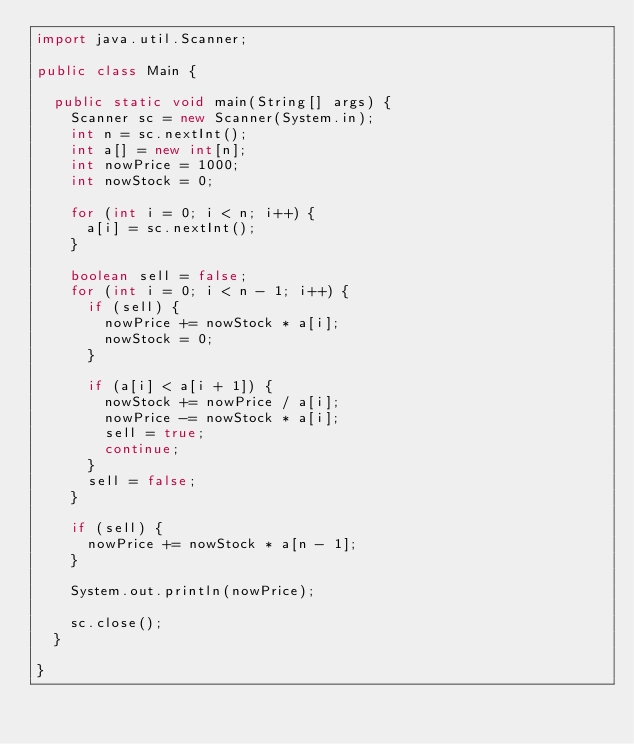<code> <loc_0><loc_0><loc_500><loc_500><_Java_>import java.util.Scanner;

public class Main {

	public static void main(String[] args) {
		Scanner sc = new Scanner(System.in);
		int n = sc.nextInt();
		int a[] = new int[n];
		int nowPrice = 1000;
		int nowStock = 0;

		for (int i = 0; i < n; i++) {
			a[i] = sc.nextInt();
		}

		boolean sell = false;
		for (int i = 0; i < n - 1; i++) {
			if (sell) {
				nowPrice += nowStock * a[i];
				nowStock = 0;
			}

			if (a[i] < a[i + 1]) {
				nowStock += nowPrice / a[i];
				nowPrice -= nowStock * a[i];
				sell = true;
				continue;
			}
			sell = false;
		}

		if (sell) {
			nowPrice += nowStock * a[n - 1];
		}

		System.out.println(nowPrice);

		sc.close();
	}

}
</code> 